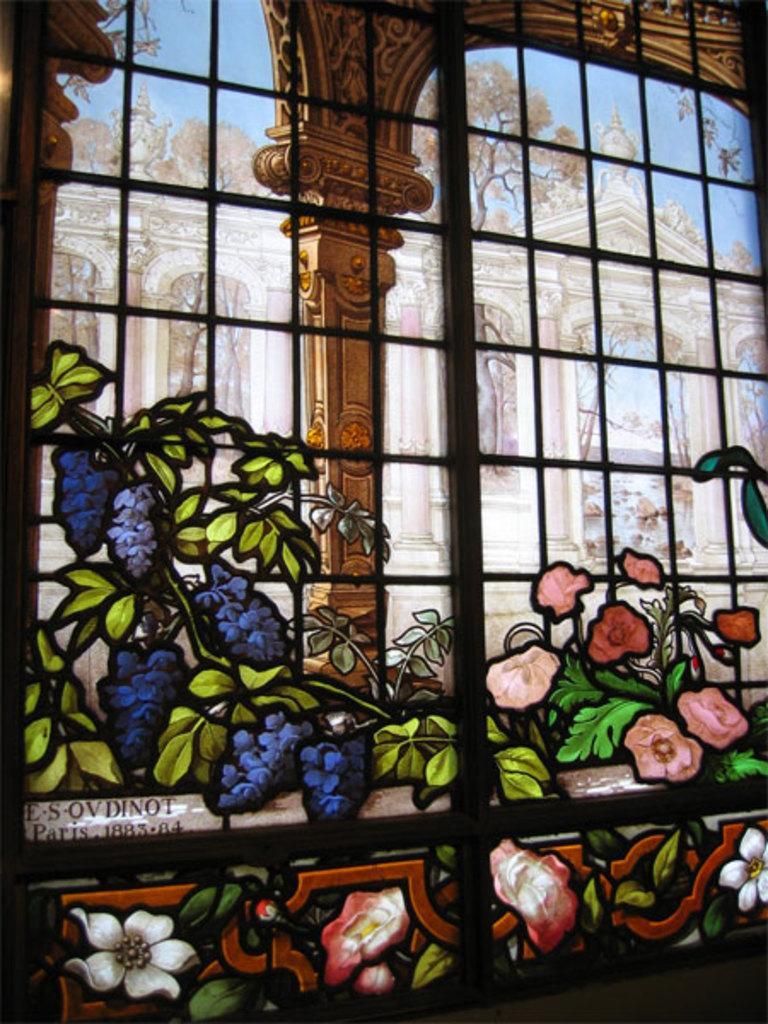How would you summarize this image in a sentence or two? In this picture I can see painting of flowers and leaves, there is a grille, and in the background there is a building, there are trees and there is the sky. 